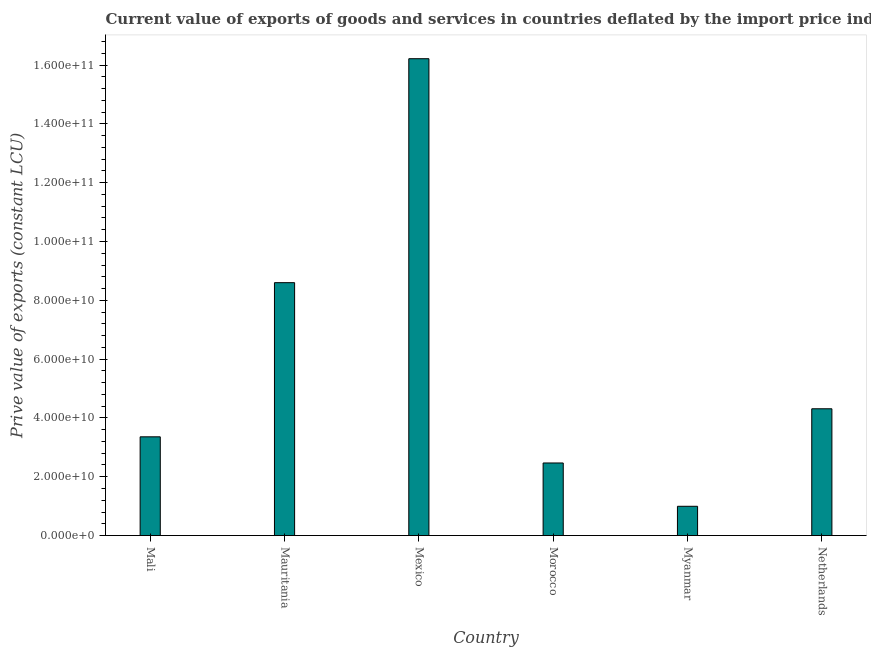Does the graph contain any zero values?
Your answer should be very brief. No. What is the title of the graph?
Your answer should be very brief. Current value of exports of goods and services in countries deflated by the import price index. What is the label or title of the X-axis?
Provide a succinct answer. Country. What is the label or title of the Y-axis?
Provide a succinct answer. Prive value of exports (constant LCU). What is the price value of exports in Mali?
Offer a very short reply. 3.36e+1. Across all countries, what is the maximum price value of exports?
Your answer should be very brief. 1.62e+11. Across all countries, what is the minimum price value of exports?
Give a very brief answer. 9.95e+09. In which country was the price value of exports minimum?
Offer a very short reply. Myanmar. What is the sum of the price value of exports?
Provide a short and direct response. 3.59e+11. What is the difference between the price value of exports in Mali and Mauritania?
Make the answer very short. -5.24e+1. What is the average price value of exports per country?
Provide a succinct answer. 5.99e+1. What is the median price value of exports?
Give a very brief answer. 3.83e+1. In how many countries, is the price value of exports greater than 40000000000 LCU?
Give a very brief answer. 3. What is the ratio of the price value of exports in Mali to that in Mauritania?
Your response must be concise. 0.39. Is the price value of exports in Mali less than that in Morocco?
Provide a short and direct response. No. What is the difference between the highest and the second highest price value of exports?
Offer a terse response. 7.62e+1. Is the sum of the price value of exports in Mauritania and Netherlands greater than the maximum price value of exports across all countries?
Offer a very short reply. No. What is the difference between the highest and the lowest price value of exports?
Your response must be concise. 1.52e+11. In how many countries, is the price value of exports greater than the average price value of exports taken over all countries?
Your answer should be compact. 2. How many bars are there?
Make the answer very short. 6. How many countries are there in the graph?
Ensure brevity in your answer.  6. What is the difference between two consecutive major ticks on the Y-axis?
Offer a terse response. 2.00e+1. Are the values on the major ticks of Y-axis written in scientific E-notation?
Ensure brevity in your answer.  Yes. What is the Prive value of exports (constant LCU) in Mali?
Your answer should be very brief. 3.36e+1. What is the Prive value of exports (constant LCU) of Mauritania?
Keep it short and to the point. 8.60e+1. What is the Prive value of exports (constant LCU) of Mexico?
Offer a terse response. 1.62e+11. What is the Prive value of exports (constant LCU) in Morocco?
Offer a very short reply. 2.47e+1. What is the Prive value of exports (constant LCU) of Myanmar?
Give a very brief answer. 9.95e+09. What is the Prive value of exports (constant LCU) in Netherlands?
Offer a very short reply. 4.31e+1. What is the difference between the Prive value of exports (constant LCU) in Mali and Mauritania?
Offer a very short reply. -5.24e+1. What is the difference between the Prive value of exports (constant LCU) in Mali and Mexico?
Your answer should be compact. -1.29e+11. What is the difference between the Prive value of exports (constant LCU) in Mali and Morocco?
Your answer should be compact. 8.90e+09. What is the difference between the Prive value of exports (constant LCU) in Mali and Myanmar?
Make the answer very short. 2.36e+1. What is the difference between the Prive value of exports (constant LCU) in Mali and Netherlands?
Give a very brief answer. -9.54e+09. What is the difference between the Prive value of exports (constant LCU) in Mauritania and Mexico?
Ensure brevity in your answer.  -7.62e+1. What is the difference between the Prive value of exports (constant LCU) in Mauritania and Morocco?
Your response must be concise. 6.13e+1. What is the difference between the Prive value of exports (constant LCU) in Mauritania and Myanmar?
Ensure brevity in your answer.  7.60e+1. What is the difference between the Prive value of exports (constant LCU) in Mauritania and Netherlands?
Offer a very short reply. 4.29e+1. What is the difference between the Prive value of exports (constant LCU) in Mexico and Morocco?
Provide a short and direct response. 1.37e+11. What is the difference between the Prive value of exports (constant LCU) in Mexico and Myanmar?
Keep it short and to the point. 1.52e+11. What is the difference between the Prive value of exports (constant LCU) in Mexico and Netherlands?
Ensure brevity in your answer.  1.19e+11. What is the difference between the Prive value of exports (constant LCU) in Morocco and Myanmar?
Offer a very short reply. 1.47e+1. What is the difference between the Prive value of exports (constant LCU) in Morocco and Netherlands?
Give a very brief answer. -1.84e+1. What is the difference between the Prive value of exports (constant LCU) in Myanmar and Netherlands?
Offer a very short reply. -3.32e+1. What is the ratio of the Prive value of exports (constant LCU) in Mali to that in Mauritania?
Make the answer very short. 0.39. What is the ratio of the Prive value of exports (constant LCU) in Mali to that in Mexico?
Provide a succinct answer. 0.21. What is the ratio of the Prive value of exports (constant LCU) in Mali to that in Morocco?
Provide a short and direct response. 1.36. What is the ratio of the Prive value of exports (constant LCU) in Mali to that in Myanmar?
Make the answer very short. 3.37. What is the ratio of the Prive value of exports (constant LCU) in Mali to that in Netherlands?
Offer a terse response. 0.78. What is the ratio of the Prive value of exports (constant LCU) in Mauritania to that in Mexico?
Offer a very short reply. 0.53. What is the ratio of the Prive value of exports (constant LCU) in Mauritania to that in Morocco?
Ensure brevity in your answer.  3.48. What is the ratio of the Prive value of exports (constant LCU) in Mauritania to that in Myanmar?
Offer a very short reply. 8.64. What is the ratio of the Prive value of exports (constant LCU) in Mauritania to that in Netherlands?
Provide a short and direct response. 2. What is the ratio of the Prive value of exports (constant LCU) in Mexico to that in Morocco?
Offer a very short reply. 6.57. What is the ratio of the Prive value of exports (constant LCU) in Mexico to that in Myanmar?
Offer a very short reply. 16.29. What is the ratio of the Prive value of exports (constant LCU) in Mexico to that in Netherlands?
Offer a very short reply. 3.76. What is the ratio of the Prive value of exports (constant LCU) in Morocco to that in Myanmar?
Offer a terse response. 2.48. What is the ratio of the Prive value of exports (constant LCU) in Morocco to that in Netherlands?
Offer a terse response. 0.57. What is the ratio of the Prive value of exports (constant LCU) in Myanmar to that in Netherlands?
Your response must be concise. 0.23. 